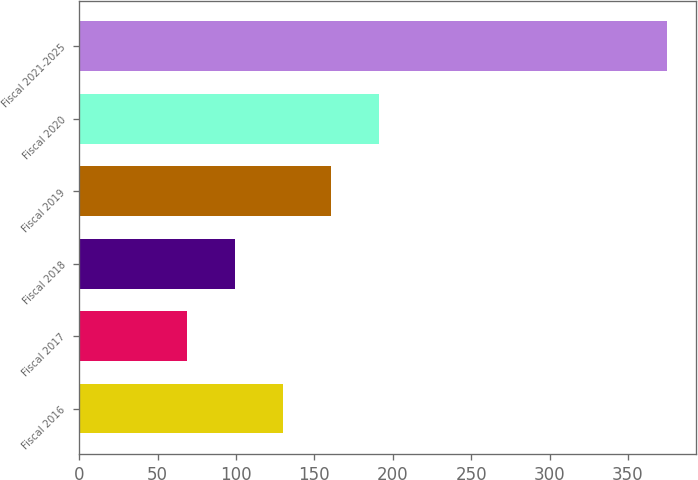Convert chart to OTSL. <chart><loc_0><loc_0><loc_500><loc_500><bar_chart><fcel>Fiscal 2016<fcel>Fiscal 2017<fcel>Fiscal 2018<fcel>Fiscal 2019<fcel>Fiscal 2020<fcel>Fiscal 2021-2025<nl><fcel>130.2<fcel>69<fcel>99.6<fcel>160.8<fcel>191.4<fcel>375<nl></chart> 